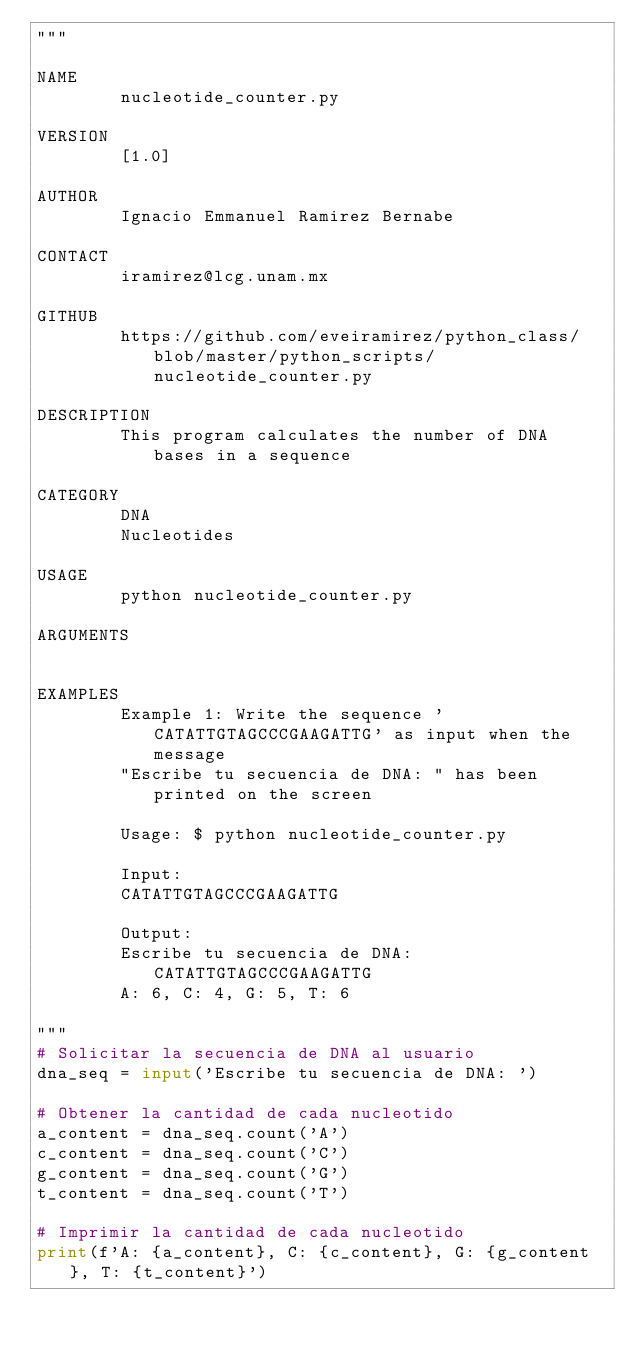Convert code to text. <code><loc_0><loc_0><loc_500><loc_500><_Python_>"""

NAME
        nucleotide_counter.py

VERSION
        [1.0]

AUTHOR
        Ignacio Emmanuel Ramirez Bernabe

CONTACT
        iramirez@lcg.unam.mx

GITHUB
        https://github.com/eveiramirez/python_class/blob/master/python_scripts/nucleotide_counter.py

DESCRIPTION
        This program calculates the number of DNA bases in a sequence

CATEGORY
        DNA
        Nucleotides

USAGE
        python nucleotide_counter.py

ARGUMENTS


EXAMPLES
        Example 1: Write the sequence 'CATATTGTAGCCCGAAGATTG' as input when the message
        "Escribe tu secuencia de DNA: " has been printed on the screen

        Usage: $ python nucleotide_counter.py

        Input:
        CATATTGTAGCCCGAAGATTG

        Output:
        Escribe tu secuencia de DNA: CATATTGTAGCCCGAAGATTG
        A: 6, C: 4, G: 5, T: 6

"""
# Solicitar la secuencia de DNA al usuario
dna_seq = input('Escribe tu secuencia de DNA: ')

# Obtener la cantidad de cada nucleotido
a_content = dna_seq.count('A')
c_content = dna_seq.count('C')
g_content = dna_seq.count('G')
t_content = dna_seq.count('T')

# Imprimir la cantidad de cada nucleotido
print(f'A: {a_content}, C: {c_content}, G: {g_content}, T: {t_content}')
</code> 